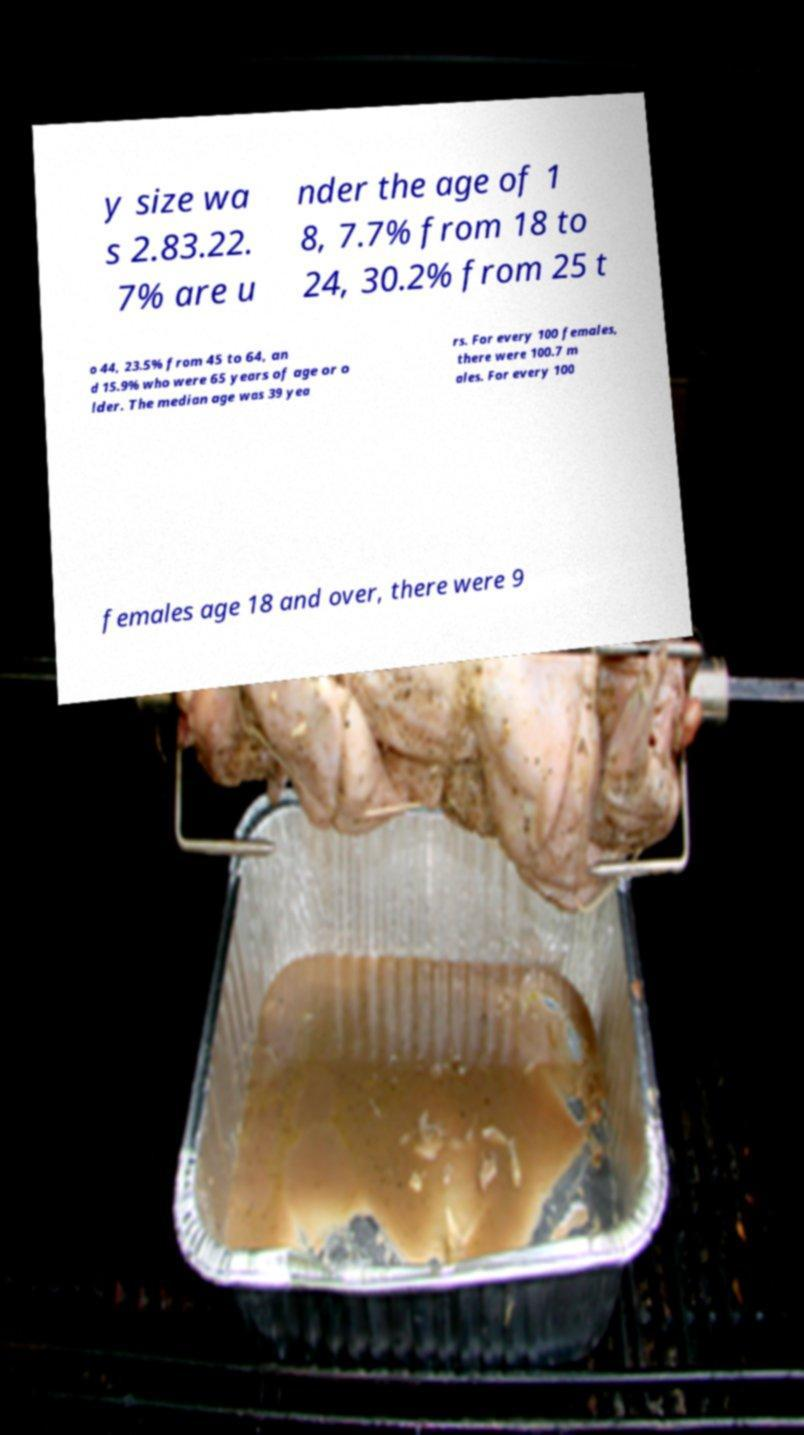Please identify and transcribe the text found in this image. y size wa s 2.83.22. 7% are u nder the age of 1 8, 7.7% from 18 to 24, 30.2% from 25 t o 44, 23.5% from 45 to 64, an d 15.9% who were 65 years of age or o lder. The median age was 39 yea rs. For every 100 females, there were 100.7 m ales. For every 100 females age 18 and over, there were 9 